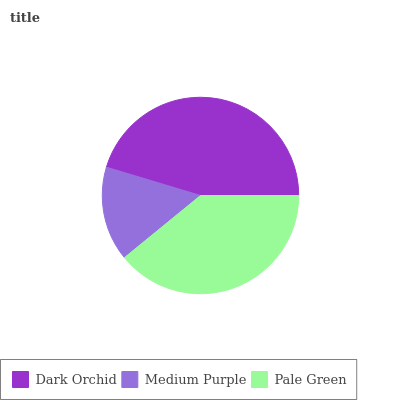Is Medium Purple the minimum?
Answer yes or no. Yes. Is Dark Orchid the maximum?
Answer yes or no. Yes. Is Pale Green the minimum?
Answer yes or no. No. Is Pale Green the maximum?
Answer yes or no. No. Is Pale Green greater than Medium Purple?
Answer yes or no. Yes. Is Medium Purple less than Pale Green?
Answer yes or no. Yes. Is Medium Purple greater than Pale Green?
Answer yes or no. No. Is Pale Green less than Medium Purple?
Answer yes or no. No. Is Pale Green the high median?
Answer yes or no. Yes. Is Pale Green the low median?
Answer yes or no. Yes. Is Medium Purple the high median?
Answer yes or no. No. Is Dark Orchid the low median?
Answer yes or no. No. 